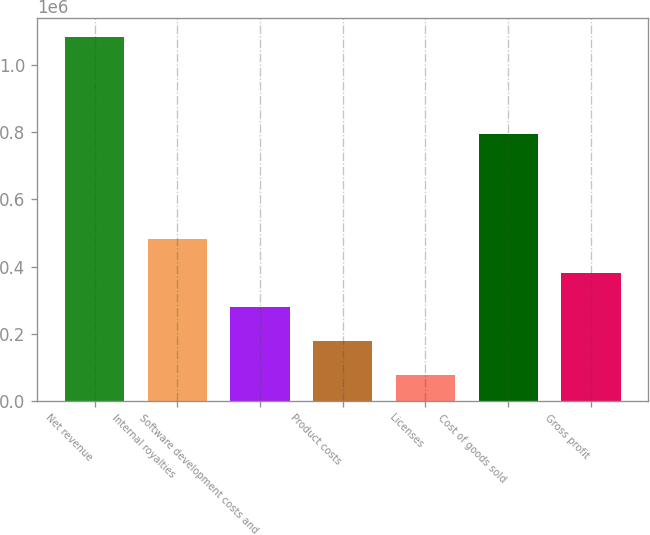Convert chart. <chart><loc_0><loc_0><loc_500><loc_500><bar_chart><fcel>Net revenue<fcel>Internal royalties<fcel>Software development costs and<fcel>Product costs<fcel>Licenses<fcel>Cost of goods sold<fcel>Gross profit<nl><fcel>1.08294e+06<fcel>480374<fcel>279331<fcel>178810<fcel>77725<fcel>794867<fcel>379853<nl></chart> 